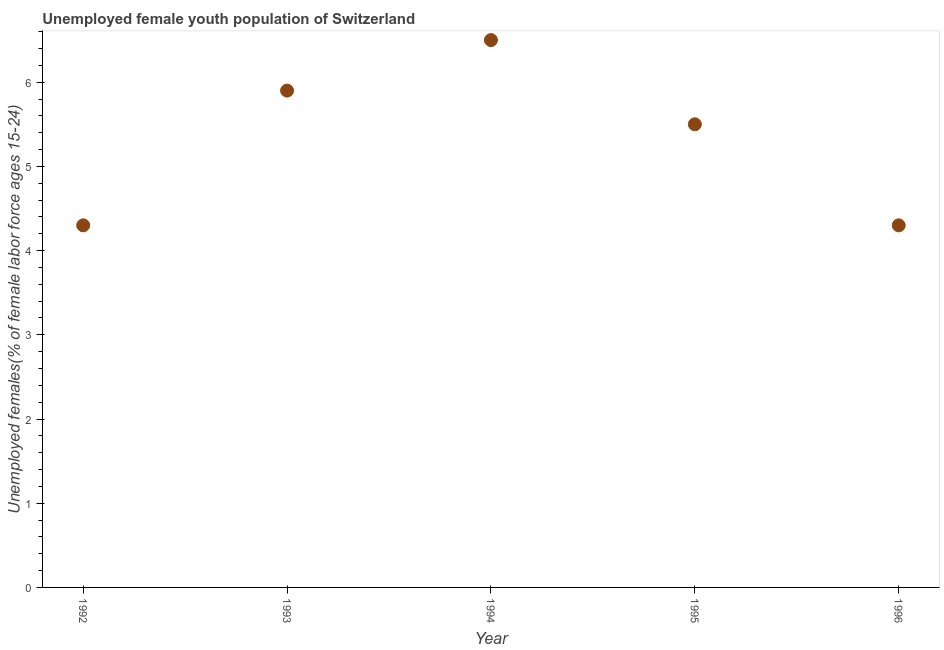Across all years, what is the maximum unemployed female youth?
Provide a succinct answer. 6.5. Across all years, what is the minimum unemployed female youth?
Offer a very short reply. 4.3. In which year was the unemployed female youth minimum?
Your response must be concise. 1992. What is the sum of the unemployed female youth?
Offer a very short reply. 26.5. What is the difference between the unemployed female youth in 1993 and 1996?
Give a very brief answer. 1.6. What is the average unemployed female youth per year?
Your response must be concise. 5.3. What is the median unemployed female youth?
Make the answer very short. 5.5. What is the ratio of the unemployed female youth in 1994 to that in 1995?
Give a very brief answer. 1.18. Is the unemployed female youth in 1992 less than that in 1993?
Provide a short and direct response. Yes. What is the difference between the highest and the second highest unemployed female youth?
Provide a succinct answer. 0.6. What is the difference between the highest and the lowest unemployed female youth?
Provide a short and direct response. 2.2. Does the unemployed female youth monotonically increase over the years?
Provide a short and direct response. No. Does the graph contain any zero values?
Your answer should be very brief. No. What is the title of the graph?
Offer a very short reply. Unemployed female youth population of Switzerland. What is the label or title of the X-axis?
Provide a short and direct response. Year. What is the label or title of the Y-axis?
Offer a terse response. Unemployed females(% of female labor force ages 15-24). What is the Unemployed females(% of female labor force ages 15-24) in 1992?
Make the answer very short. 4.3. What is the Unemployed females(% of female labor force ages 15-24) in 1993?
Provide a succinct answer. 5.9. What is the Unemployed females(% of female labor force ages 15-24) in 1996?
Ensure brevity in your answer.  4.3. What is the difference between the Unemployed females(% of female labor force ages 15-24) in 1992 and 1993?
Provide a succinct answer. -1.6. What is the difference between the Unemployed females(% of female labor force ages 15-24) in 1992 and 1994?
Offer a very short reply. -2.2. What is the difference between the Unemployed females(% of female labor force ages 15-24) in 1992 and 1996?
Your response must be concise. 0. What is the difference between the Unemployed females(% of female labor force ages 15-24) in 1994 and 1996?
Keep it short and to the point. 2.2. What is the difference between the Unemployed females(% of female labor force ages 15-24) in 1995 and 1996?
Give a very brief answer. 1.2. What is the ratio of the Unemployed females(% of female labor force ages 15-24) in 1992 to that in 1993?
Your response must be concise. 0.73. What is the ratio of the Unemployed females(% of female labor force ages 15-24) in 1992 to that in 1994?
Provide a succinct answer. 0.66. What is the ratio of the Unemployed females(% of female labor force ages 15-24) in 1992 to that in 1995?
Your answer should be compact. 0.78. What is the ratio of the Unemployed females(% of female labor force ages 15-24) in 1993 to that in 1994?
Make the answer very short. 0.91. What is the ratio of the Unemployed females(% of female labor force ages 15-24) in 1993 to that in 1995?
Ensure brevity in your answer.  1.07. What is the ratio of the Unemployed females(% of female labor force ages 15-24) in 1993 to that in 1996?
Provide a succinct answer. 1.37. What is the ratio of the Unemployed females(% of female labor force ages 15-24) in 1994 to that in 1995?
Your response must be concise. 1.18. What is the ratio of the Unemployed females(% of female labor force ages 15-24) in 1994 to that in 1996?
Provide a succinct answer. 1.51. What is the ratio of the Unemployed females(% of female labor force ages 15-24) in 1995 to that in 1996?
Provide a short and direct response. 1.28. 